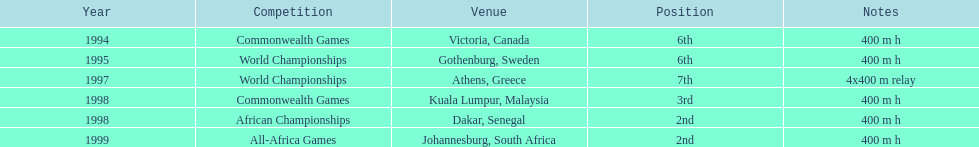What is the last competition on the chart? All-Africa Games. 